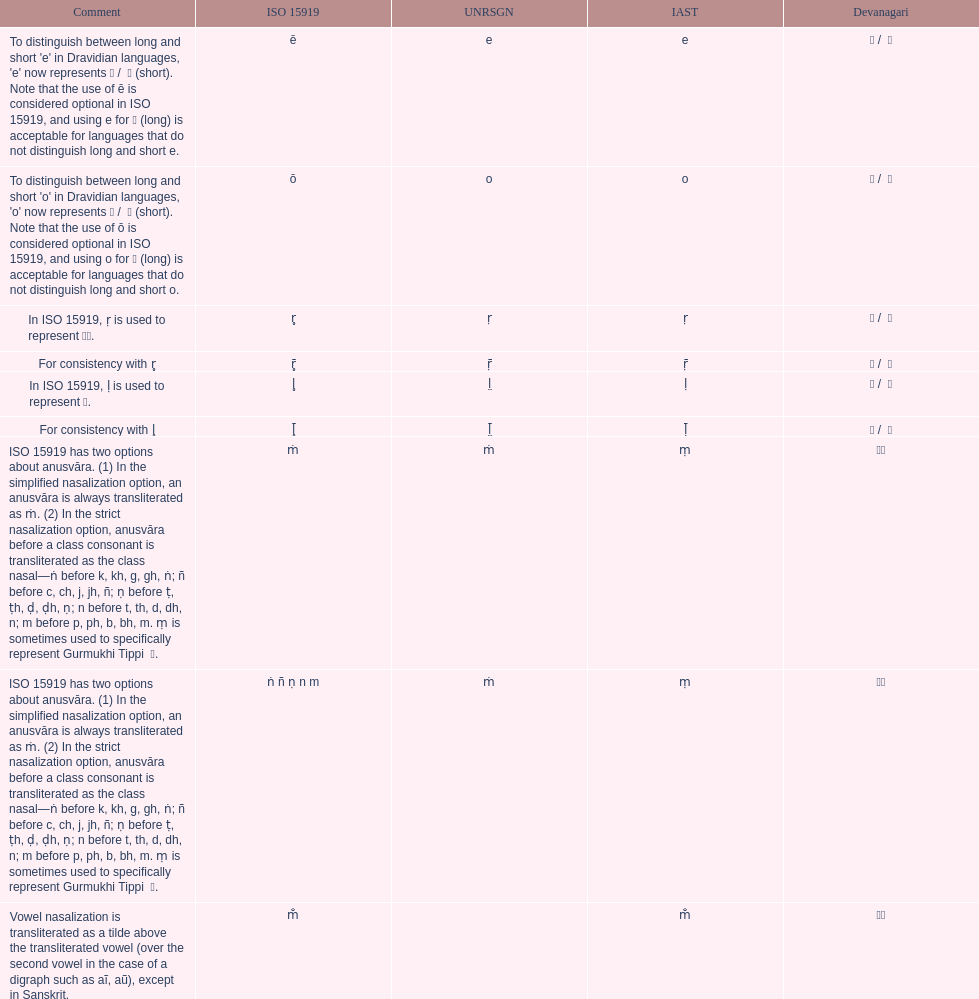What iast is listed before the o? E. 